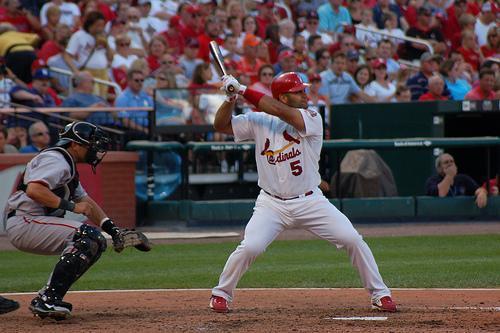How many people are swinging a bat in this photo?
Give a very brief answer. 1. How many baseball players are visible?
Give a very brief answer. 2. How many people are swinging a bat?
Give a very brief answer. 1. How many people are crouching?
Give a very brief answer. 1. 